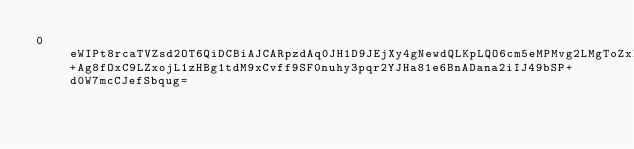Convert code to text. <code><loc_0><loc_0><loc_500><loc_500><_SML_>0eWIPt8rcaTVZsd2OT6QiDCBiAJCARpzdAq0JH1D9JEjXy4gNewdQLKpLQO6cm5eMPMvg2LMgToZxIPO2ctLqE77xPnGiHvaAYzJZlv9F841YcABpiqZAkIB0h6P+Ag8fOxC9LZxojL1zHBg1tdM9xCvff9SF0nuhy3pqr2YJHa81e6BnADana2iIJ49bSP+d0W7mcCJefSbqug=</code> 